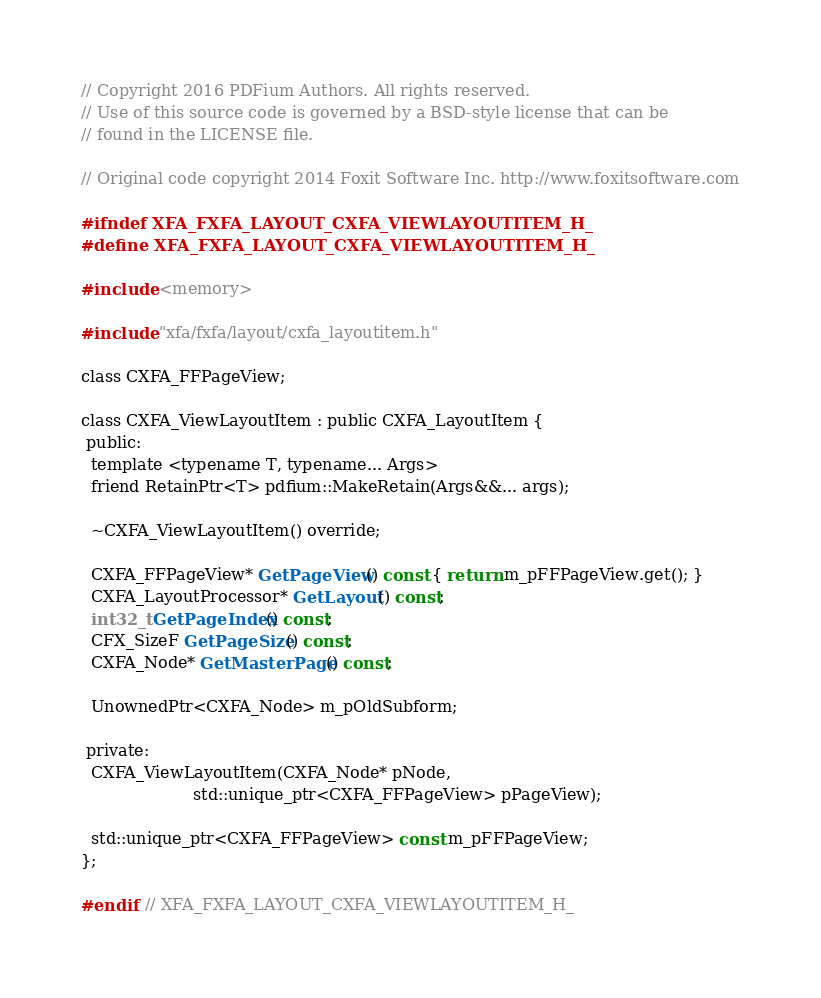Convert code to text. <code><loc_0><loc_0><loc_500><loc_500><_C_>// Copyright 2016 PDFium Authors. All rights reserved.
// Use of this source code is governed by a BSD-style license that can be
// found in the LICENSE file.

// Original code copyright 2014 Foxit Software Inc. http://www.foxitsoftware.com

#ifndef XFA_FXFA_LAYOUT_CXFA_VIEWLAYOUTITEM_H_
#define XFA_FXFA_LAYOUT_CXFA_VIEWLAYOUTITEM_H_

#include <memory>

#include "xfa/fxfa/layout/cxfa_layoutitem.h"

class CXFA_FFPageView;

class CXFA_ViewLayoutItem : public CXFA_LayoutItem {
 public:
  template <typename T, typename... Args>
  friend RetainPtr<T> pdfium::MakeRetain(Args&&... args);

  ~CXFA_ViewLayoutItem() override;

  CXFA_FFPageView* GetPageView() const { return m_pFFPageView.get(); }
  CXFA_LayoutProcessor* GetLayout() const;
  int32_t GetPageIndex() const;
  CFX_SizeF GetPageSize() const;
  CXFA_Node* GetMasterPage() const;

  UnownedPtr<CXFA_Node> m_pOldSubform;

 private:
  CXFA_ViewLayoutItem(CXFA_Node* pNode,
                      std::unique_ptr<CXFA_FFPageView> pPageView);

  std::unique_ptr<CXFA_FFPageView> const m_pFFPageView;
};

#endif  // XFA_FXFA_LAYOUT_CXFA_VIEWLAYOUTITEM_H_
</code> 